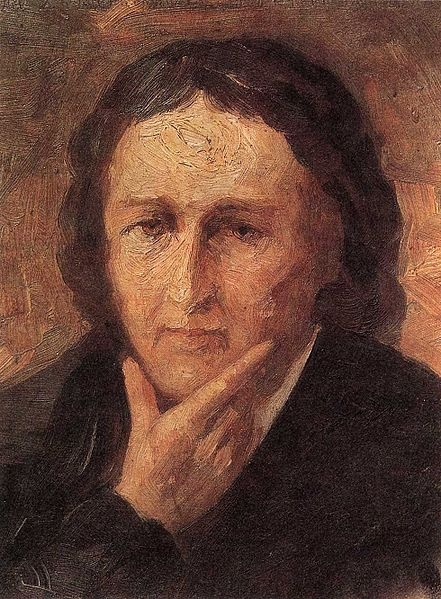Can you create a short poetic description inspired by this portrait? In silent gaze, a soul reflects,
Where thoughts in shadows slowly weave,
In somber hues the past connects,
A web of stories we perceive.
With brush and stroke, emotions caught,
A canvas whispers what’s unseen,
In contemplation deeply fraught,
The portrait tells a tale serene. 